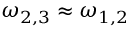<formula> <loc_0><loc_0><loc_500><loc_500>\omega _ { 2 , 3 } \approx \omega _ { 1 , 2 }</formula> 